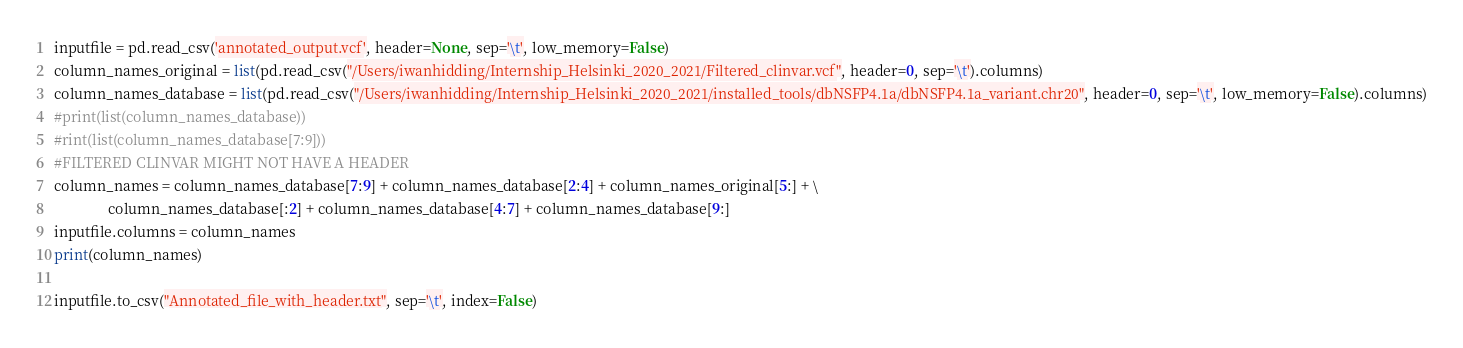<code> <loc_0><loc_0><loc_500><loc_500><_Python_>inputfile = pd.read_csv('annotated_output.vcf', header=None, sep='\t', low_memory=False)
column_names_original = list(pd.read_csv("/Users/iwanhidding/Internship_Helsinki_2020_2021/Filtered_clinvar.vcf", header=0, sep='\t').columns)
column_names_database = list(pd.read_csv("/Users/iwanhidding/Internship_Helsinki_2020_2021/installed_tools/dbNSFP4.1a/dbNSFP4.1a_variant.chr20", header=0, sep='\t', low_memory=False).columns)
#print(list(column_names_database))
#rint(list(column_names_database[7:9]))
#FILTERED CLINVAR MIGHT NOT HAVE A HEADER
column_names = column_names_database[7:9] + column_names_database[2:4] + column_names_original[5:] + \
               column_names_database[:2] + column_names_database[4:7] + column_names_database[9:]
inputfile.columns = column_names
print(column_names)

inputfile.to_csv("Annotated_file_with_header.txt", sep='\t', index=False)
</code> 